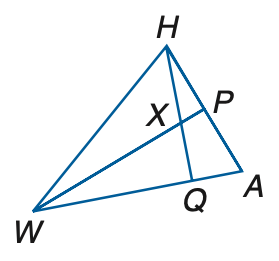Question: If W P is a perpendicular bisector, m \angle W H A = 8 q + 17, m \angle H W P = 10 + q, A P = 6 r + 4, and P H = 22 + 3 r, find m \angle H W P.
Choices:
A. 15
B. 16
C. 17
D. 18
Answer with the letter. Answer: C Question: If W P is a perpendicular bisector, m \angle W H A = 8 q + 17, m \angle H W P = 10 + q, A P = 6 r + 4, and P H = 22 + 3 r, find r.
Choices:
A. 6
B. 7
C. 8
D. 9
Answer with the letter. Answer: A Question: If W P is a median and an angle bisector, A P = 3 y + 11, P H = 7 y - 5, m \angle H W P = x + 12, m \angle P A W = 3 x - 2, and m \angle H W A = 4 x - 16, find y.
Choices:
A. 3
B. 4
C. 5
D. 6
Answer with the letter. Answer: B Question: If W P is a perpendicular bisector, m \angle W H A = 8 q + 17, m \angle H W P = 10 + q, A P = 6 r + 4, and P H = 22 + 3 r, find q.
Choices:
A. 5
B. 6
C. 7
D. 8
Answer with the letter. Answer: C Question: If W P is a median and an angle bisector, A P = 3 y + 11, P H = 7 y - 5, m \angle H W P = x + 12, m \angle P A W = 3 x - 2, and m \angle H W A = 4 x - 16, find x.
Choices:
A. 20
B. 24
C. 28
D. 32
Answer with the letter. Answer: A 